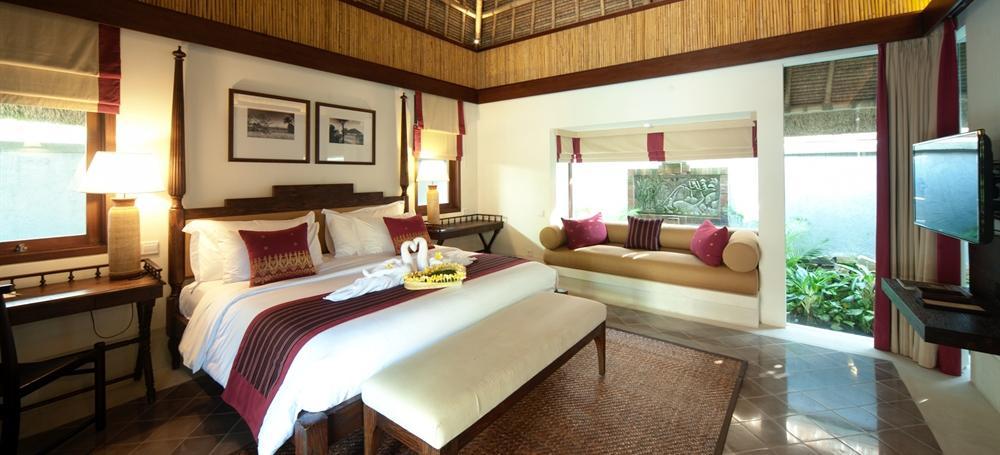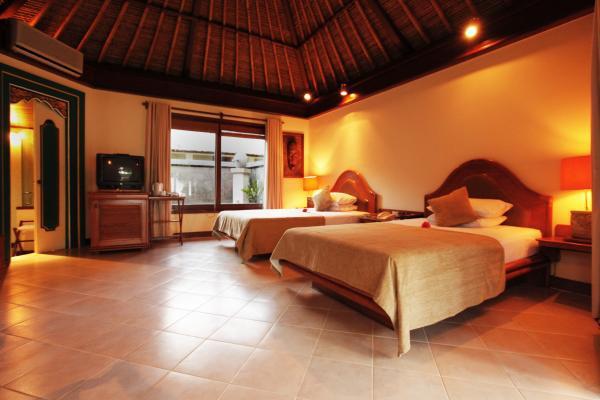The first image is the image on the left, the second image is the image on the right. Considering the images on both sides, is "The left and right image contains both an external view of the building and internal view of a resort." valid? Answer yes or no. No. The first image is the image on the left, the second image is the image on the right. Assess this claim about the two images: "Both images are inside.". Correct or not? Answer yes or no. Yes. 